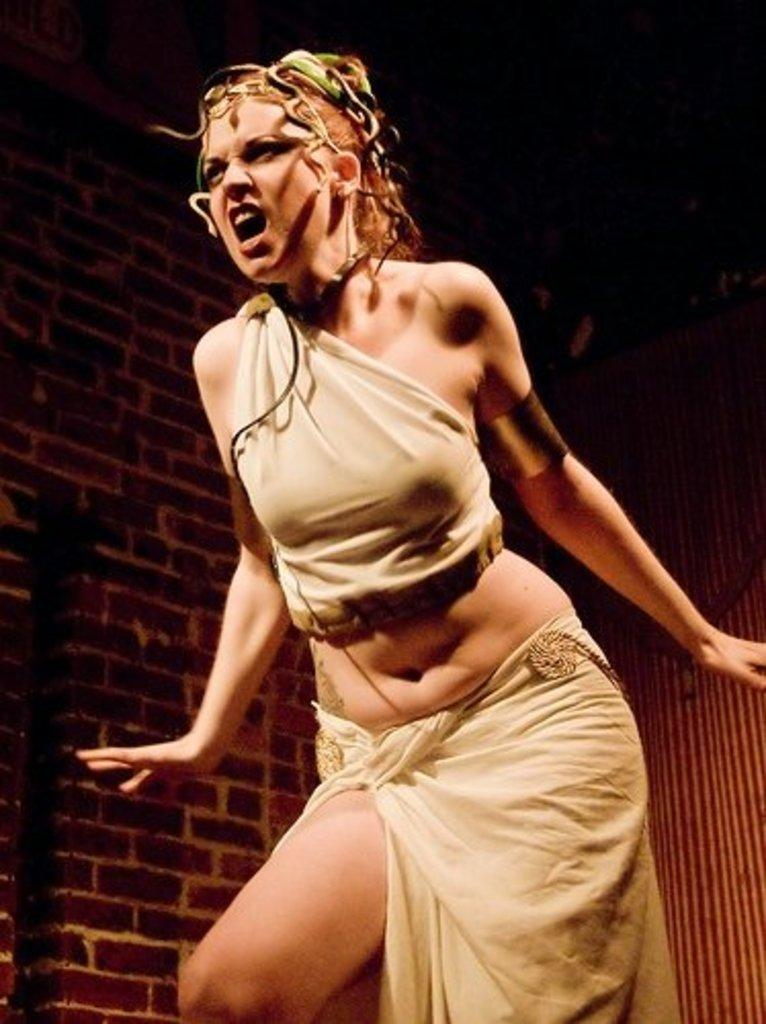What is the main subject of the image? There is a woman standing in the image. Can you describe the woman's facial expression? The woman has an expression on her face. What can be seen in the background of the image? There is a wall in the background of the image. What type of vessel is the woman using to create her artwork in the image? There is no vessel or artwork present in the image; it only features a woman standing with a facial expression. What color is the creator's outfit in the image? There is no creator mentioned in the image, and the woman's outfit color is not specified. 